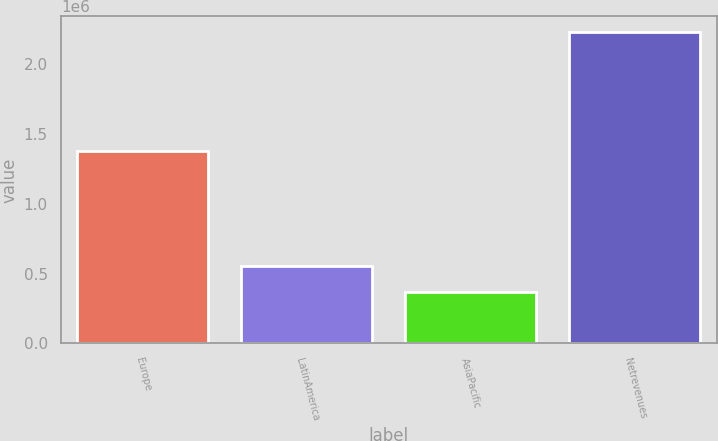<chart> <loc_0><loc_0><loc_500><loc_500><bar_chart><fcel>Europe<fcel>LatinAmerica<fcel>AsiaPacific<fcel>Netrevenues<nl><fcel>1.38195e+06<fcel>553246<fcel>366542<fcel>2.23358e+06<nl></chart> 